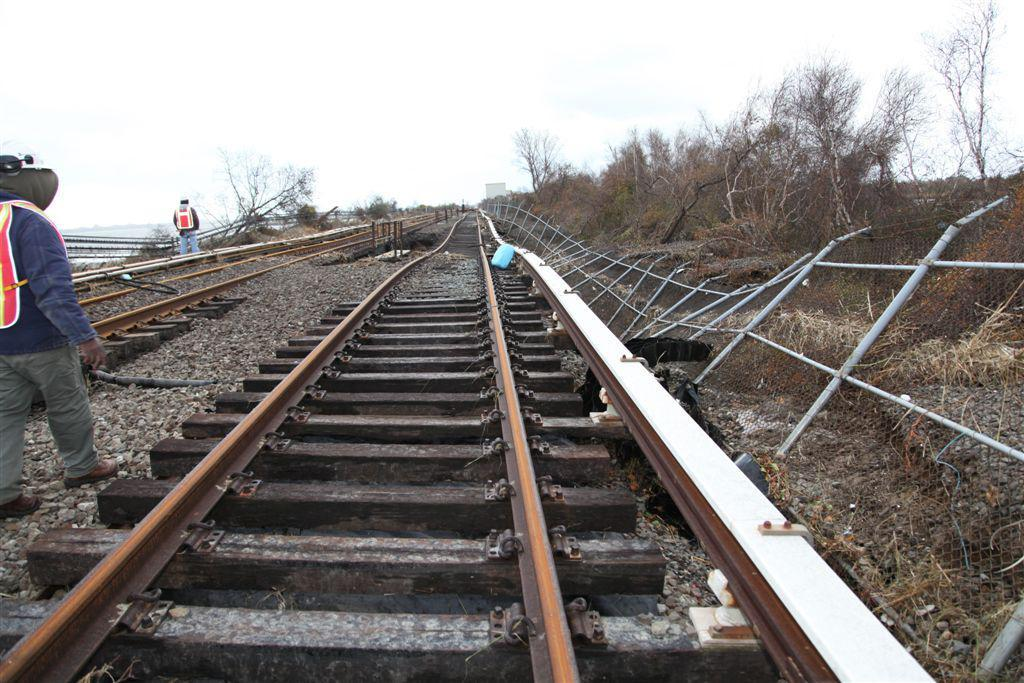How many people are in the image? There are two persons in the image. What are the persons doing in the image? The persons are standing near railway tracks. What type of vegetation is present in the image? There are trees in the image. What is visible barrier is present in the image? There is a fence in the image. What can be seen in the background of the image? A: The sky is visible in the background of the image. What type of spark can be seen between the two persons in the image? There is no spark visible between the two persons in the image. What type of love is expressed by the two persons in the image? There is no indication of love or emotion between the two persons in the image; they are simply standing near railway tracks. 